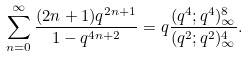Convert formula to latex. <formula><loc_0><loc_0><loc_500><loc_500>\sum _ { n = 0 } ^ { \infty } \frac { ( 2 n + 1 ) q ^ { 2 n + 1 } } { 1 - q ^ { 4 n + 2 } } = q \frac { ( q ^ { 4 } ; q ^ { 4 } ) _ { \infty } ^ { 8 } } { ( q ^ { 2 } ; q ^ { 2 } ) _ { \infty } ^ { 4 } } .</formula> 